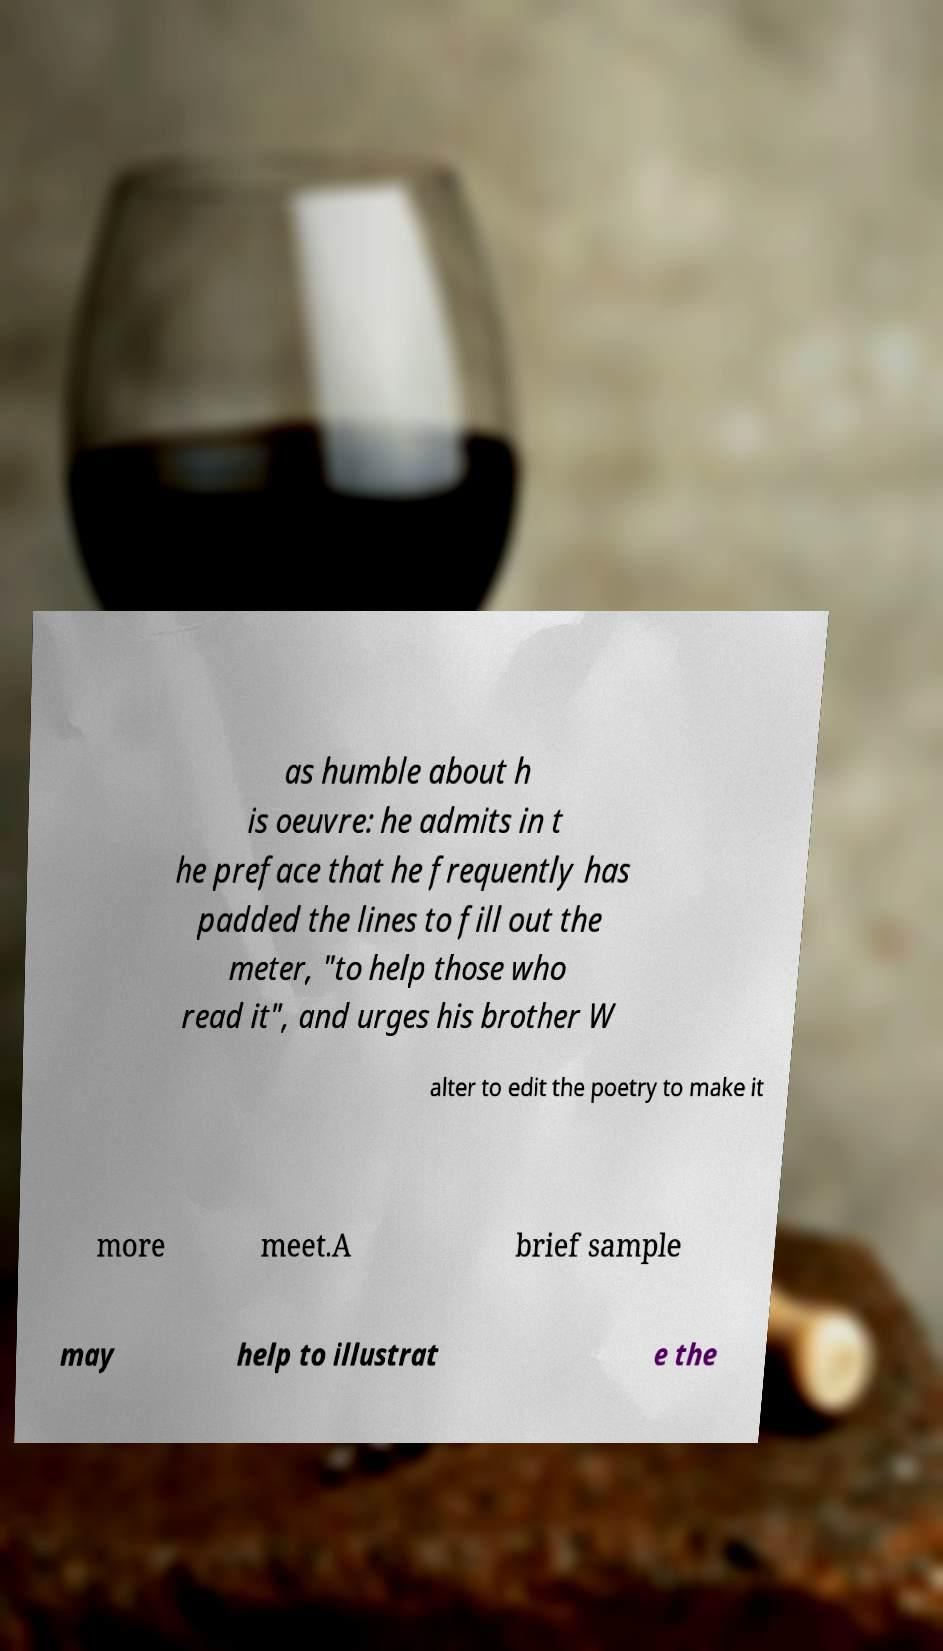Please identify and transcribe the text found in this image. as humble about h is oeuvre: he admits in t he preface that he frequently has padded the lines to fill out the meter, "to help those who read it", and urges his brother W alter to edit the poetry to make it more meet.A brief sample may help to illustrat e the 